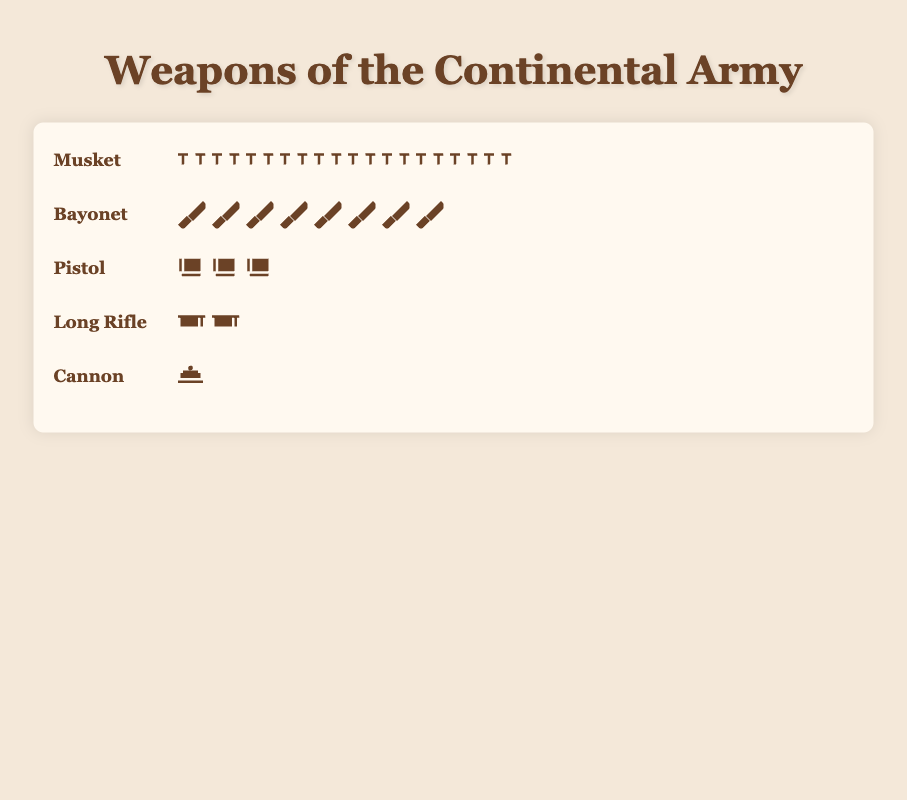What's the total number of muskets used by the Continental Army? Refer to the row labeled "Musket" and count the number of musket icons depicted. Since each icon represents one musket, you can tally up the total easily. The count of icons is 100.
Answer: 100 Which weapon had the second highest count? First, identify the counts of each weapon: Musket (100), Bayonet (80), Pistol (30), Long Rifle (20), Cannon (10). The weapon with the second highest count is the Bayonet with 80 followed by Musket with 100.
Answer: Bayonet How many more muskets were used than cannons? Determine the count for muskets (100) and cannons (10). Subtract the number of cannons from muskets: 100 - 10 = 90.
Answer: 90 Which weapon is the least used by the Continental Army? Identify the weapon with the smallest count by comparing the numbers for all weapons: Cannon (10) has the smallest count among Musket, Bayonet, Pistol, Long Rifle, and Cannon.
Answer: Cannon How many weapons in total were used by the Continental Army? Sum the counts of all the weapons: 100 (Musket) + 80 (Bayonet) + 30 (Pistol) + 20 (Long Rifle) + 10 (Cannon). The total is 240.
Answer: 240 How many more bayonets and muskets were there compared to pistols and long rifles combined? Sum the counts of bayonets (80) and muskets (100): 80 + 100 = 180. Sum the counts of pistols (30) and long rifles (20): 30 + 20 = 50. Subtract the second sum from the first: 180 - 50 = 130.
Answer: 130 What percentage of the total weapons does the musket represent? The total number of weapons is 240. The number of muskets is 100. Calculate the percentage using (100/240) * 100. This equals approximately 41.67%.
Answer: 41.67% Which is used more: pistols or long rifles? Compare the counts of pistols (30) and long rifles (20). Pistols have a higher count than long rifles.
Answer: Pistols What is the average count of all the weapons? Add the counts for all the weapons: 240. Divide this sum by the total number of different weapons (5). So, the average is 240 / 5 = 48.
Answer: 48 If each icon represents one unit of the weapon, how many icons in total should be displayed in the figure? Count up all the icons for each weapon: 100 (Musket) + 80 (Bayonet) + 30 (Pistol) + 20 (Long Rifle) + 10 (Cannon). The total number of icons is 240.
Answer: 240 